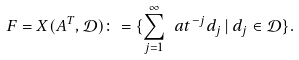<formula> <loc_0><loc_0><loc_500><loc_500>F = X ( A ^ { T } , \mathcal { D } ) \colon = \{ \sum _ { j = 1 } ^ { \infty } \ a t ^ { - j } d _ { j } \, | \, d _ { j } \in \mathcal { D } \} .</formula> 